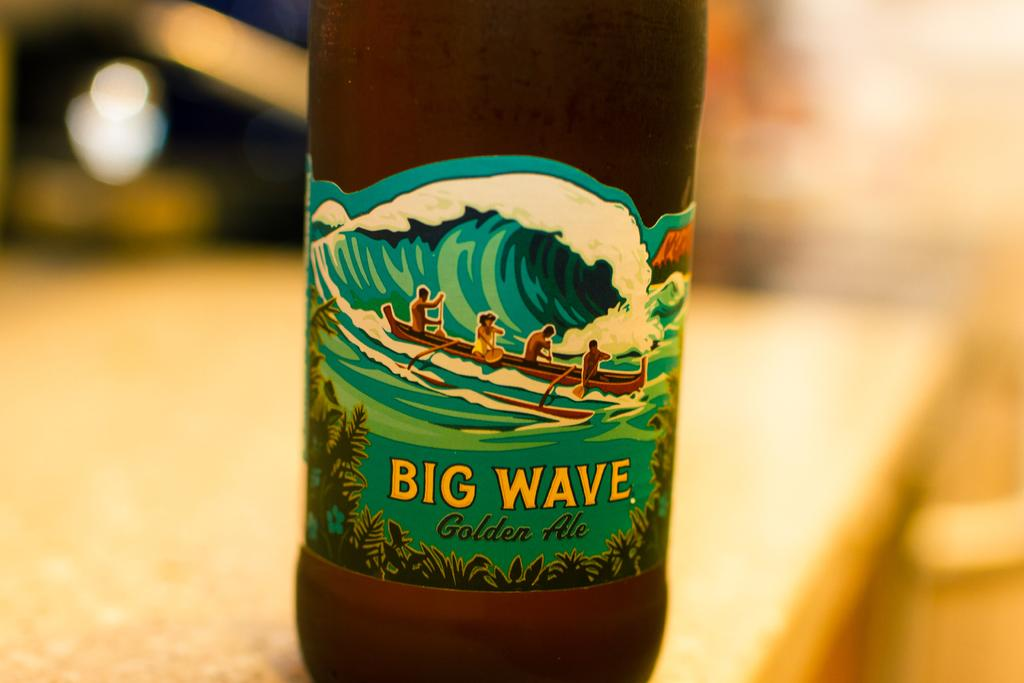Provide a one-sentence caption for the provided image. The label for Big Wave Golden Ale includes people in a kayak. 